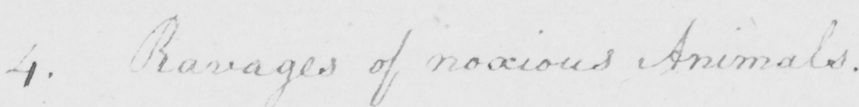Can you tell me what this handwritten text says? 4 . Ravages of noxious Animals . 